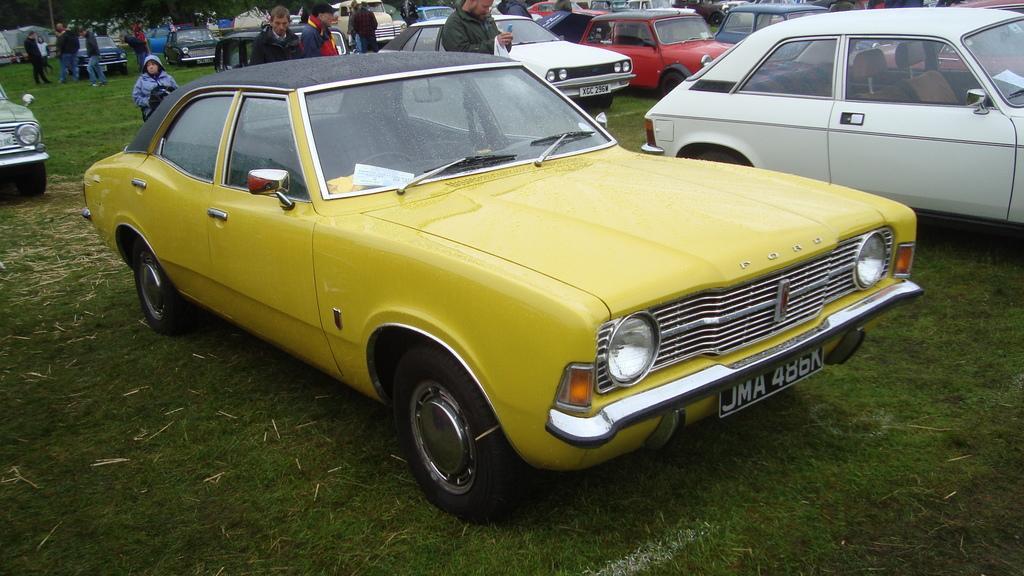In one or two sentences, can you explain what this image depicts? In the center of the image we can see a few vehicles in different colors. In the background, we can see one tent, grass, vehicles, few people are standing, few people are holding some objects and a few other objects. 